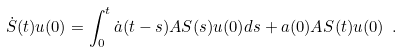Convert formula to latex. <formula><loc_0><loc_0><loc_500><loc_500>\dot { S } ( t ) u ( 0 ) = \int _ { 0 } ^ { t } \dot { a } ( t - s ) A S ( s ) u ( 0 ) d s + a ( 0 ) A S ( t ) u ( 0 ) \ .</formula> 